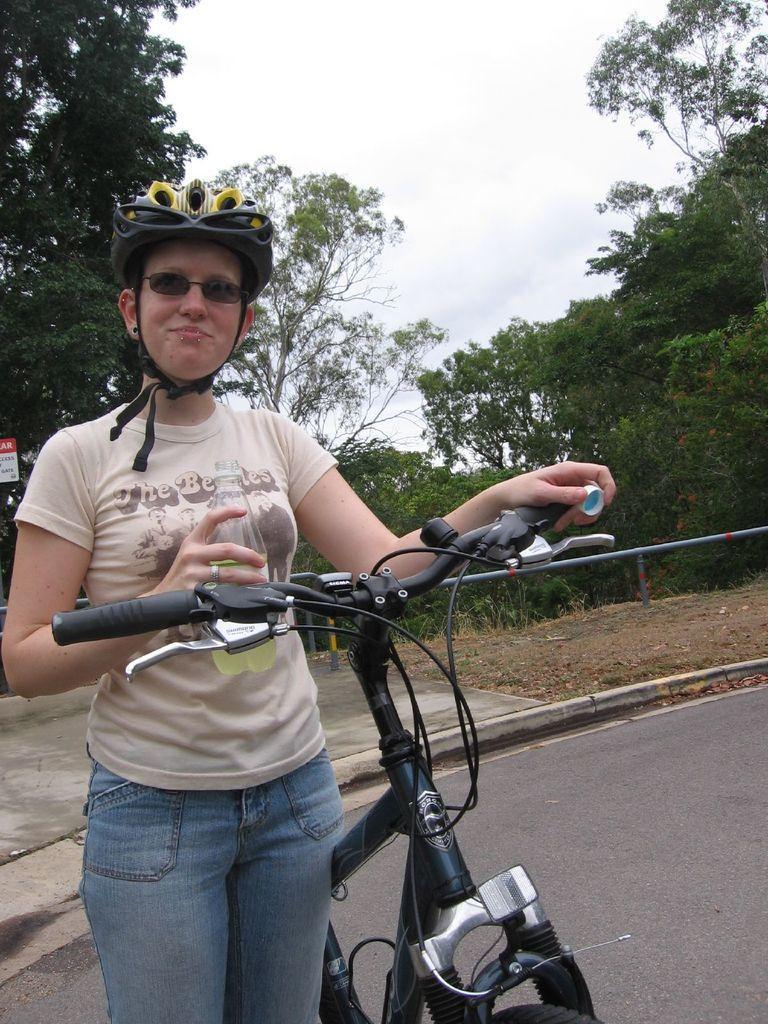Can you describe this image briefly? In this image we can see a lady is standing on the road and holding a bicycle and a bottle in her hand. In the background of the image we can see trees and the sky. 